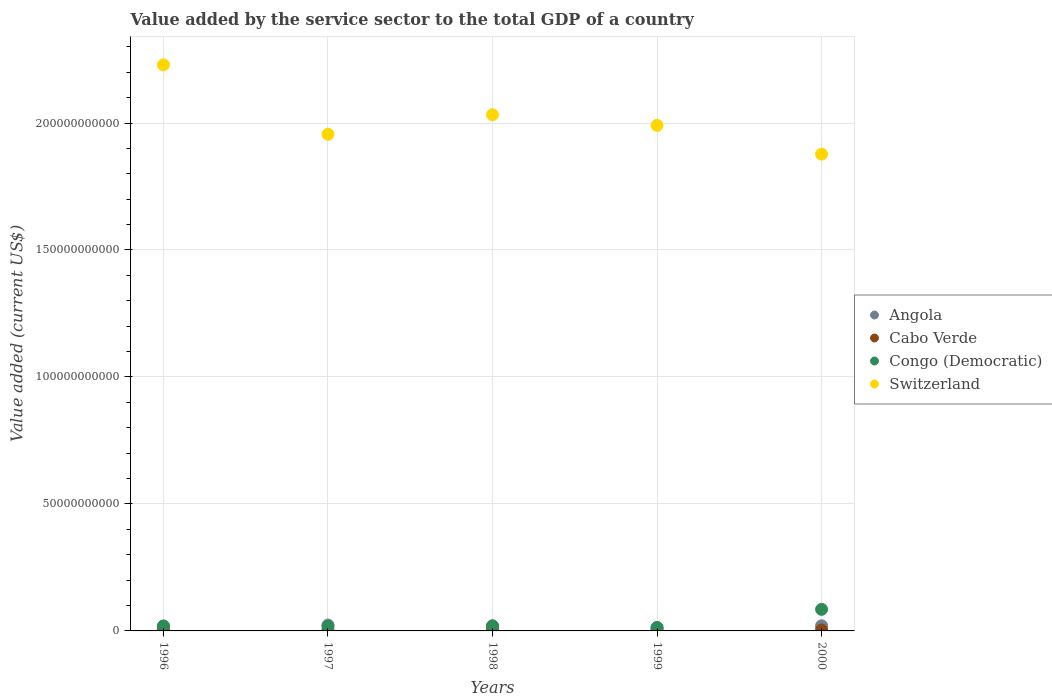How many different coloured dotlines are there?
Your response must be concise. 4. Is the number of dotlines equal to the number of legend labels?
Your answer should be compact. Yes. What is the value added by the service sector to the total GDP in Congo (Democratic) in 1997?
Make the answer very short. 1.82e+09. Across all years, what is the maximum value added by the service sector to the total GDP in Cabo Verde?
Your answer should be compact. 3.73e+08. Across all years, what is the minimum value added by the service sector to the total GDP in Congo (Democratic)?
Your response must be concise. 1.33e+09. In which year was the value added by the service sector to the total GDP in Congo (Democratic) minimum?
Give a very brief answer. 1999. What is the total value added by the service sector to the total GDP in Cabo Verde in the graph?
Offer a very short reply. 1.65e+09. What is the difference between the value added by the service sector to the total GDP in Cabo Verde in 1997 and that in 1998?
Provide a short and direct response. -2.24e+07. What is the difference between the value added by the service sector to the total GDP in Cabo Verde in 2000 and the value added by the service sector to the total GDP in Congo (Democratic) in 1996?
Provide a succinct answer. -1.58e+09. What is the average value added by the service sector to the total GDP in Angola per year?
Provide a succinct answer. 1.91e+09. In the year 2000, what is the difference between the value added by the service sector to the total GDP in Congo (Democratic) and value added by the service sector to the total GDP in Angola?
Keep it short and to the point. 6.47e+09. What is the ratio of the value added by the service sector to the total GDP in Congo (Democratic) in 1997 to that in 2000?
Offer a very short reply. 0.21. What is the difference between the highest and the second highest value added by the service sector to the total GDP in Cabo Verde?
Provide a short and direct response. 2.05e+07. What is the difference between the highest and the lowest value added by the service sector to the total GDP in Congo (Democratic)?
Your response must be concise. 7.16e+09. In how many years, is the value added by the service sector to the total GDP in Switzerland greater than the average value added by the service sector to the total GDP in Switzerland taken over all years?
Your answer should be compact. 2. Is the sum of the value added by the service sector to the total GDP in Angola in 1997 and 1998 greater than the maximum value added by the service sector to the total GDP in Congo (Democratic) across all years?
Your response must be concise. No. Is it the case that in every year, the sum of the value added by the service sector to the total GDP in Switzerland and value added by the service sector to the total GDP in Congo (Democratic)  is greater than the sum of value added by the service sector to the total GDP in Cabo Verde and value added by the service sector to the total GDP in Angola?
Provide a succinct answer. Yes. Does the value added by the service sector to the total GDP in Congo (Democratic) monotonically increase over the years?
Your response must be concise. No. Is the value added by the service sector to the total GDP in Angola strictly greater than the value added by the service sector to the total GDP in Cabo Verde over the years?
Your response must be concise. Yes. How many dotlines are there?
Give a very brief answer. 4. Are the values on the major ticks of Y-axis written in scientific E-notation?
Your answer should be very brief. No. Does the graph contain any zero values?
Offer a very short reply. No. Does the graph contain grids?
Your answer should be very brief. Yes. Where does the legend appear in the graph?
Your response must be concise. Center right. How are the legend labels stacked?
Give a very brief answer. Vertical. What is the title of the graph?
Your answer should be very brief. Value added by the service sector to the total GDP of a country. What is the label or title of the X-axis?
Offer a terse response. Years. What is the label or title of the Y-axis?
Offer a very short reply. Value added (current US$). What is the Value added (current US$) of Angola in 1996?
Provide a succinct answer. 1.89e+09. What is the Value added (current US$) of Cabo Verde in 1996?
Keep it short and to the point. 2.94e+08. What is the Value added (current US$) of Congo (Democratic) in 1996?
Keep it short and to the point. 1.93e+09. What is the Value added (current US$) of Switzerland in 1996?
Your response must be concise. 2.23e+11. What is the Value added (current US$) of Angola in 1997?
Provide a succinct answer. 2.31e+09. What is the Value added (current US$) of Cabo Verde in 1997?
Make the answer very short. 3.05e+08. What is the Value added (current US$) in Congo (Democratic) in 1997?
Ensure brevity in your answer.  1.82e+09. What is the Value added (current US$) in Switzerland in 1997?
Offer a terse response. 1.96e+11. What is the Value added (current US$) of Angola in 1998?
Your answer should be very brief. 2.02e+09. What is the Value added (current US$) in Cabo Verde in 1998?
Your answer should be compact. 3.27e+08. What is the Value added (current US$) of Congo (Democratic) in 1998?
Your response must be concise. 1.93e+09. What is the Value added (current US$) of Switzerland in 1998?
Give a very brief answer. 2.03e+11. What is the Value added (current US$) of Angola in 1999?
Your answer should be very brief. 1.29e+09. What is the Value added (current US$) in Cabo Verde in 1999?
Offer a terse response. 3.73e+08. What is the Value added (current US$) in Congo (Democratic) in 1999?
Offer a terse response. 1.33e+09. What is the Value added (current US$) in Switzerland in 1999?
Your answer should be compact. 1.99e+11. What is the Value added (current US$) in Angola in 2000?
Ensure brevity in your answer.  2.03e+09. What is the Value added (current US$) of Cabo Verde in 2000?
Provide a short and direct response. 3.53e+08. What is the Value added (current US$) of Congo (Democratic) in 2000?
Offer a terse response. 8.50e+09. What is the Value added (current US$) in Switzerland in 2000?
Your answer should be very brief. 1.88e+11. Across all years, what is the maximum Value added (current US$) of Angola?
Offer a very short reply. 2.31e+09. Across all years, what is the maximum Value added (current US$) in Cabo Verde?
Your answer should be very brief. 3.73e+08. Across all years, what is the maximum Value added (current US$) of Congo (Democratic)?
Your response must be concise. 8.50e+09. Across all years, what is the maximum Value added (current US$) in Switzerland?
Provide a succinct answer. 2.23e+11. Across all years, what is the minimum Value added (current US$) in Angola?
Your answer should be very brief. 1.29e+09. Across all years, what is the minimum Value added (current US$) of Cabo Verde?
Offer a very short reply. 2.94e+08. Across all years, what is the minimum Value added (current US$) of Congo (Democratic)?
Give a very brief answer. 1.33e+09. Across all years, what is the minimum Value added (current US$) of Switzerland?
Ensure brevity in your answer.  1.88e+11. What is the total Value added (current US$) of Angola in the graph?
Ensure brevity in your answer.  9.54e+09. What is the total Value added (current US$) of Cabo Verde in the graph?
Provide a short and direct response. 1.65e+09. What is the total Value added (current US$) in Congo (Democratic) in the graph?
Offer a terse response. 1.55e+1. What is the total Value added (current US$) in Switzerland in the graph?
Provide a succinct answer. 1.01e+12. What is the difference between the Value added (current US$) in Angola in 1996 and that in 1997?
Ensure brevity in your answer.  -4.20e+08. What is the difference between the Value added (current US$) of Cabo Verde in 1996 and that in 1997?
Offer a terse response. -1.05e+07. What is the difference between the Value added (current US$) in Congo (Democratic) in 1996 and that in 1997?
Offer a terse response. 1.12e+08. What is the difference between the Value added (current US$) in Switzerland in 1996 and that in 1997?
Provide a succinct answer. 2.73e+1. What is the difference between the Value added (current US$) in Angola in 1996 and that in 1998?
Provide a short and direct response. -1.23e+08. What is the difference between the Value added (current US$) of Cabo Verde in 1996 and that in 1998?
Offer a very short reply. -3.28e+07. What is the difference between the Value added (current US$) in Congo (Democratic) in 1996 and that in 1998?
Your response must be concise. 8.81e+06. What is the difference between the Value added (current US$) in Switzerland in 1996 and that in 1998?
Provide a succinct answer. 1.96e+1. What is the difference between the Value added (current US$) of Angola in 1996 and that in 1999?
Offer a very short reply. 6.02e+08. What is the difference between the Value added (current US$) of Cabo Verde in 1996 and that in 1999?
Give a very brief answer. -7.88e+07. What is the difference between the Value added (current US$) in Congo (Democratic) in 1996 and that in 1999?
Offer a very short reply. 6.02e+08. What is the difference between the Value added (current US$) of Switzerland in 1996 and that in 1999?
Offer a terse response. 2.39e+1. What is the difference between the Value added (current US$) of Angola in 1996 and that in 2000?
Offer a very short reply. -1.35e+08. What is the difference between the Value added (current US$) in Cabo Verde in 1996 and that in 2000?
Ensure brevity in your answer.  -5.83e+07. What is the difference between the Value added (current US$) in Congo (Democratic) in 1996 and that in 2000?
Your response must be concise. -6.56e+09. What is the difference between the Value added (current US$) in Switzerland in 1996 and that in 2000?
Your response must be concise. 3.52e+1. What is the difference between the Value added (current US$) of Angola in 1997 and that in 1998?
Offer a terse response. 2.97e+08. What is the difference between the Value added (current US$) of Cabo Verde in 1997 and that in 1998?
Your answer should be very brief. -2.24e+07. What is the difference between the Value added (current US$) in Congo (Democratic) in 1997 and that in 1998?
Give a very brief answer. -1.03e+08. What is the difference between the Value added (current US$) in Switzerland in 1997 and that in 1998?
Provide a succinct answer. -7.70e+09. What is the difference between the Value added (current US$) of Angola in 1997 and that in 1999?
Your answer should be compact. 1.02e+09. What is the difference between the Value added (current US$) of Cabo Verde in 1997 and that in 1999?
Provide a succinct answer. -6.84e+07. What is the difference between the Value added (current US$) of Congo (Democratic) in 1997 and that in 1999?
Your answer should be very brief. 4.90e+08. What is the difference between the Value added (current US$) in Switzerland in 1997 and that in 1999?
Provide a succinct answer. -3.50e+09. What is the difference between the Value added (current US$) in Angola in 1997 and that in 2000?
Keep it short and to the point. 2.85e+08. What is the difference between the Value added (current US$) in Cabo Verde in 1997 and that in 2000?
Provide a short and direct response. -4.78e+07. What is the difference between the Value added (current US$) of Congo (Democratic) in 1997 and that in 2000?
Ensure brevity in your answer.  -6.67e+09. What is the difference between the Value added (current US$) in Switzerland in 1997 and that in 2000?
Provide a short and direct response. 7.81e+09. What is the difference between the Value added (current US$) of Angola in 1998 and that in 1999?
Your answer should be compact. 7.25e+08. What is the difference between the Value added (current US$) in Cabo Verde in 1998 and that in 1999?
Provide a short and direct response. -4.60e+07. What is the difference between the Value added (current US$) in Congo (Democratic) in 1998 and that in 1999?
Your answer should be compact. 5.93e+08. What is the difference between the Value added (current US$) of Switzerland in 1998 and that in 1999?
Provide a short and direct response. 4.21e+09. What is the difference between the Value added (current US$) in Angola in 1998 and that in 2000?
Your answer should be very brief. -1.14e+07. What is the difference between the Value added (current US$) of Cabo Verde in 1998 and that in 2000?
Give a very brief answer. -2.54e+07. What is the difference between the Value added (current US$) of Congo (Democratic) in 1998 and that in 2000?
Your answer should be very brief. -6.57e+09. What is the difference between the Value added (current US$) of Switzerland in 1998 and that in 2000?
Offer a very short reply. 1.55e+1. What is the difference between the Value added (current US$) in Angola in 1999 and that in 2000?
Ensure brevity in your answer.  -7.36e+08. What is the difference between the Value added (current US$) in Cabo Verde in 1999 and that in 2000?
Ensure brevity in your answer.  2.05e+07. What is the difference between the Value added (current US$) in Congo (Democratic) in 1999 and that in 2000?
Provide a short and direct response. -7.16e+09. What is the difference between the Value added (current US$) in Switzerland in 1999 and that in 2000?
Your answer should be compact. 1.13e+1. What is the difference between the Value added (current US$) in Angola in 1996 and the Value added (current US$) in Cabo Verde in 1997?
Offer a very short reply. 1.59e+09. What is the difference between the Value added (current US$) of Angola in 1996 and the Value added (current US$) of Congo (Democratic) in 1997?
Provide a succinct answer. 7.04e+07. What is the difference between the Value added (current US$) of Angola in 1996 and the Value added (current US$) of Switzerland in 1997?
Keep it short and to the point. -1.94e+11. What is the difference between the Value added (current US$) of Cabo Verde in 1996 and the Value added (current US$) of Congo (Democratic) in 1997?
Make the answer very short. -1.53e+09. What is the difference between the Value added (current US$) of Cabo Verde in 1996 and the Value added (current US$) of Switzerland in 1997?
Provide a short and direct response. -1.95e+11. What is the difference between the Value added (current US$) in Congo (Democratic) in 1996 and the Value added (current US$) in Switzerland in 1997?
Your response must be concise. -1.94e+11. What is the difference between the Value added (current US$) of Angola in 1996 and the Value added (current US$) of Cabo Verde in 1998?
Your response must be concise. 1.57e+09. What is the difference between the Value added (current US$) of Angola in 1996 and the Value added (current US$) of Congo (Democratic) in 1998?
Give a very brief answer. -3.28e+07. What is the difference between the Value added (current US$) in Angola in 1996 and the Value added (current US$) in Switzerland in 1998?
Provide a short and direct response. -2.01e+11. What is the difference between the Value added (current US$) in Cabo Verde in 1996 and the Value added (current US$) in Congo (Democratic) in 1998?
Give a very brief answer. -1.63e+09. What is the difference between the Value added (current US$) in Cabo Verde in 1996 and the Value added (current US$) in Switzerland in 1998?
Provide a succinct answer. -2.03e+11. What is the difference between the Value added (current US$) of Congo (Democratic) in 1996 and the Value added (current US$) of Switzerland in 1998?
Keep it short and to the point. -2.01e+11. What is the difference between the Value added (current US$) in Angola in 1996 and the Value added (current US$) in Cabo Verde in 1999?
Offer a terse response. 1.52e+09. What is the difference between the Value added (current US$) of Angola in 1996 and the Value added (current US$) of Congo (Democratic) in 1999?
Keep it short and to the point. 5.60e+08. What is the difference between the Value added (current US$) of Angola in 1996 and the Value added (current US$) of Switzerland in 1999?
Offer a very short reply. -1.97e+11. What is the difference between the Value added (current US$) of Cabo Verde in 1996 and the Value added (current US$) of Congo (Democratic) in 1999?
Provide a succinct answer. -1.04e+09. What is the difference between the Value added (current US$) of Cabo Verde in 1996 and the Value added (current US$) of Switzerland in 1999?
Offer a terse response. -1.99e+11. What is the difference between the Value added (current US$) in Congo (Democratic) in 1996 and the Value added (current US$) in Switzerland in 1999?
Your answer should be very brief. -1.97e+11. What is the difference between the Value added (current US$) of Angola in 1996 and the Value added (current US$) of Cabo Verde in 2000?
Your answer should be compact. 1.54e+09. What is the difference between the Value added (current US$) in Angola in 1996 and the Value added (current US$) in Congo (Democratic) in 2000?
Offer a very short reply. -6.60e+09. What is the difference between the Value added (current US$) of Angola in 1996 and the Value added (current US$) of Switzerland in 2000?
Make the answer very short. -1.86e+11. What is the difference between the Value added (current US$) in Cabo Verde in 1996 and the Value added (current US$) in Congo (Democratic) in 2000?
Provide a short and direct response. -8.20e+09. What is the difference between the Value added (current US$) of Cabo Verde in 1996 and the Value added (current US$) of Switzerland in 2000?
Your response must be concise. -1.87e+11. What is the difference between the Value added (current US$) of Congo (Democratic) in 1996 and the Value added (current US$) of Switzerland in 2000?
Keep it short and to the point. -1.86e+11. What is the difference between the Value added (current US$) in Angola in 1997 and the Value added (current US$) in Cabo Verde in 1998?
Give a very brief answer. 1.99e+09. What is the difference between the Value added (current US$) of Angola in 1997 and the Value added (current US$) of Congo (Democratic) in 1998?
Provide a short and direct response. 3.87e+08. What is the difference between the Value added (current US$) in Angola in 1997 and the Value added (current US$) in Switzerland in 1998?
Offer a terse response. -2.01e+11. What is the difference between the Value added (current US$) in Cabo Verde in 1997 and the Value added (current US$) in Congo (Democratic) in 1998?
Your answer should be compact. -1.62e+09. What is the difference between the Value added (current US$) in Cabo Verde in 1997 and the Value added (current US$) in Switzerland in 1998?
Offer a very short reply. -2.03e+11. What is the difference between the Value added (current US$) of Congo (Democratic) in 1997 and the Value added (current US$) of Switzerland in 1998?
Provide a succinct answer. -2.01e+11. What is the difference between the Value added (current US$) in Angola in 1997 and the Value added (current US$) in Cabo Verde in 1999?
Your answer should be very brief. 1.94e+09. What is the difference between the Value added (current US$) of Angola in 1997 and the Value added (current US$) of Congo (Democratic) in 1999?
Give a very brief answer. 9.80e+08. What is the difference between the Value added (current US$) in Angola in 1997 and the Value added (current US$) in Switzerland in 1999?
Your answer should be compact. -1.97e+11. What is the difference between the Value added (current US$) in Cabo Verde in 1997 and the Value added (current US$) in Congo (Democratic) in 1999?
Give a very brief answer. -1.03e+09. What is the difference between the Value added (current US$) in Cabo Verde in 1997 and the Value added (current US$) in Switzerland in 1999?
Make the answer very short. -1.99e+11. What is the difference between the Value added (current US$) of Congo (Democratic) in 1997 and the Value added (current US$) of Switzerland in 1999?
Your response must be concise. -1.97e+11. What is the difference between the Value added (current US$) of Angola in 1997 and the Value added (current US$) of Cabo Verde in 2000?
Give a very brief answer. 1.96e+09. What is the difference between the Value added (current US$) in Angola in 1997 and the Value added (current US$) in Congo (Democratic) in 2000?
Ensure brevity in your answer.  -6.18e+09. What is the difference between the Value added (current US$) in Angola in 1997 and the Value added (current US$) in Switzerland in 2000?
Offer a very short reply. -1.85e+11. What is the difference between the Value added (current US$) of Cabo Verde in 1997 and the Value added (current US$) of Congo (Democratic) in 2000?
Give a very brief answer. -8.19e+09. What is the difference between the Value added (current US$) of Cabo Verde in 1997 and the Value added (current US$) of Switzerland in 2000?
Your answer should be very brief. -1.87e+11. What is the difference between the Value added (current US$) in Congo (Democratic) in 1997 and the Value added (current US$) in Switzerland in 2000?
Make the answer very short. -1.86e+11. What is the difference between the Value added (current US$) in Angola in 1998 and the Value added (current US$) in Cabo Verde in 1999?
Ensure brevity in your answer.  1.64e+09. What is the difference between the Value added (current US$) in Angola in 1998 and the Value added (current US$) in Congo (Democratic) in 1999?
Provide a short and direct response. 6.83e+08. What is the difference between the Value added (current US$) of Angola in 1998 and the Value added (current US$) of Switzerland in 1999?
Your answer should be compact. -1.97e+11. What is the difference between the Value added (current US$) in Cabo Verde in 1998 and the Value added (current US$) in Congo (Democratic) in 1999?
Give a very brief answer. -1.01e+09. What is the difference between the Value added (current US$) of Cabo Verde in 1998 and the Value added (current US$) of Switzerland in 1999?
Ensure brevity in your answer.  -1.99e+11. What is the difference between the Value added (current US$) in Congo (Democratic) in 1998 and the Value added (current US$) in Switzerland in 1999?
Provide a short and direct response. -1.97e+11. What is the difference between the Value added (current US$) of Angola in 1998 and the Value added (current US$) of Cabo Verde in 2000?
Make the answer very short. 1.66e+09. What is the difference between the Value added (current US$) of Angola in 1998 and the Value added (current US$) of Congo (Democratic) in 2000?
Ensure brevity in your answer.  -6.48e+09. What is the difference between the Value added (current US$) of Angola in 1998 and the Value added (current US$) of Switzerland in 2000?
Give a very brief answer. -1.86e+11. What is the difference between the Value added (current US$) of Cabo Verde in 1998 and the Value added (current US$) of Congo (Democratic) in 2000?
Provide a succinct answer. -8.17e+09. What is the difference between the Value added (current US$) of Cabo Verde in 1998 and the Value added (current US$) of Switzerland in 2000?
Offer a very short reply. -1.87e+11. What is the difference between the Value added (current US$) in Congo (Democratic) in 1998 and the Value added (current US$) in Switzerland in 2000?
Provide a succinct answer. -1.86e+11. What is the difference between the Value added (current US$) of Angola in 1999 and the Value added (current US$) of Cabo Verde in 2000?
Keep it short and to the point. 9.39e+08. What is the difference between the Value added (current US$) of Angola in 1999 and the Value added (current US$) of Congo (Democratic) in 2000?
Ensure brevity in your answer.  -7.21e+09. What is the difference between the Value added (current US$) of Angola in 1999 and the Value added (current US$) of Switzerland in 2000?
Your response must be concise. -1.86e+11. What is the difference between the Value added (current US$) of Cabo Verde in 1999 and the Value added (current US$) of Congo (Democratic) in 2000?
Provide a succinct answer. -8.12e+09. What is the difference between the Value added (current US$) in Cabo Verde in 1999 and the Value added (current US$) in Switzerland in 2000?
Your answer should be very brief. -1.87e+11. What is the difference between the Value added (current US$) in Congo (Democratic) in 1999 and the Value added (current US$) in Switzerland in 2000?
Your answer should be very brief. -1.86e+11. What is the average Value added (current US$) of Angola per year?
Give a very brief answer. 1.91e+09. What is the average Value added (current US$) in Cabo Verde per year?
Your answer should be very brief. 3.30e+08. What is the average Value added (current US$) of Congo (Democratic) per year?
Your response must be concise. 3.10e+09. What is the average Value added (current US$) of Switzerland per year?
Provide a short and direct response. 2.02e+11. In the year 1996, what is the difference between the Value added (current US$) of Angola and Value added (current US$) of Cabo Verde?
Your answer should be very brief. 1.60e+09. In the year 1996, what is the difference between the Value added (current US$) in Angola and Value added (current US$) in Congo (Democratic)?
Ensure brevity in your answer.  -4.16e+07. In the year 1996, what is the difference between the Value added (current US$) of Angola and Value added (current US$) of Switzerland?
Your answer should be very brief. -2.21e+11. In the year 1996, what is the difference between the Value added (current US$) of Cabo Verde and Value added (current US$) of Congo (Democratic)?
Make the answer very short. -1.64e+09. In the year 1996, what is the difference between the Value added (current US$) of Cabo Verde and Value added (current US$) of Switzerland?
Make the answer very short. -2.23e+11. In the year 1996, what is the difference between the Value added (current US$) of Congo (Democratic) and Value added (current US$) of Switzerland?
Provide a succinct answer. -2.21e+11. In the year 1997, what is the difference between the Value added (current US$) in Angola and Value added (current US$) in Cabo Verde?
Offer a terse response. 2.01e+09. In the year 1997, what is the difference between the Value added (current US$) in Angola and Value added (current US$) in Congo (Democratic)?
Offer a terse response. 4.90e+08. In the year 1997, what is the difference between the Value added (current US$) of Angola and Value added (current US$) of Switzerland?
Make the answer very short. -1.93e+11. In the year 1997, what is the difference between the Value added (current US$) in Cabo Verde and Value added (current US$) in Congo (Democratic)?
Offer a terse response. -1.52e+09. In the year 1997, what is the difference between the Value added (current US$) in Cabo Verde and Value added (current US$) in Switzerland?
Offer a very short reply. -1.95e+11. In the year 1997, what is the difference between the Value added (current US$) of Congo (Democratic) and Value added (current US$) of Switzerland?
Provide a succinct answer. -1.94e+11. In the year 1998, what is the difference between the Value added (current US$) of Angola and Value added (current US$) of Cabo Verde?
Your answer should be very brief. 1.69e+09. In the year 1998, what is the difference between the Value added (current US$) of Angola and Value added (current US$) of Congo (Democratic)?
Provide a short and direct response. 9.05e+07. In the year 1998, what is the difference between the Value added (current US$) of Angola and Value added (current US$) of Switzerland?
Ensure brevity in your answer.  -2.01e+11. In the year 1998, what is the difference between the Value added (current US$) of Cabo Verde and Value added (current US$) of Congo (Democratic)?
Provide a succinct answer. -1.60e+09. In the year 1998, what is the difference between the Value added (current US$) in Cabo Verde and Value added (current US$) in Switzerland?
Your answer should be very brief. -2.03e+11. In the year 1998, what is the difference between the Value added (current US$) of Congo (Democratic) and Value added (current US$) of Switzerland?
Your answer should be very brief. -2.01e+11. In the year 1999, what is the difference between the Value added (current US$) in Angola and Value added (current US$) in Cabo Verde?
Provide a succinct answer. 9.19e+08. In the year 1999, what is the difference between the Value added (current US$) in Angola and Value added (current US$) in Congo (Democratic)?
Give a very brief answer. -4.14e+07. In the year 1999, what is the difference between the Value added (current US$) in Angola and Value added (current US$) in Switzerland?
Make the answer very short. -1.98e+11. In the year 1999, what is the difference between the Value added (current US$) of Cabo Verde and Value added (current US$) of Congo (Democratic)?
Give a very brief answer. -9.60e+08. In the year 1999, what is the difference between the Value added (current US$) in Cabo Verde and Value added (current US$) in Switzerland?
Offer a very short reply. -1.99e+11. In the year 1999, what is the difference between the Value added (current US$) in Congo (Democratic) and Value added (current US$) in Switzerland?
Provide a short and direct response. -1.98e+11. In the year 2000, what is the difference between the Value added (current US$) of Angola and Value added (current US$) of Cabo Verde?
Give a very brief answer. 1.68e+09. In the year 2000, what is the difference between the Value added (current US$) of Angola and Value added (current US$) of Congo (Democratic)?
Offer a very short reply. -6.47e+09. In the year 2000, what is the difference between the Value added (current US$) of Angola and Value added (current US$) of Switzerland?
Your answer should be compact. -1.86e+11. In the year 2000, what is the difference between the Value added (current US$) of Cabo Verde and Value added (current US$) of Congo (Democratic)?
Make the answer very short. -8.14e+09. In the year 2000, what is the difference between the Value added (current US$) in Cabo Verde and Value added (current US$) in Switzerland?
Ensure brevity in your answer.  -1.87e+11. In the year 2000, what is the difference between the Value added (current US$) of Congo (Democratic) and Value added (current US$) of Switzerland?
Ensure brevity in your answer.  -1.79e+11. What is the ratio of the Value added (current US$) in Angola in 1996 to that in 1997?
Provide a succinct answer. 0.82. What is the ratio of the Value added (current US$) of Cabo Verde in 1996 to that in 1997?
Offer a terse response. 0.97. What is the ratio of the Value added (current US$) of Congo (Democratic) in 1996 to that in 1997?
Your answer should be compact. 1.06. What is the ratio of the Value added (current US$) of Switzerland in 1996 to that in 1997?
Ensure brevity in your answer.  1.14. What is the ratio of the Value added (current US$) of Angola in 1996 to that in 1998?
Your response must be concise. 0.94. What is the ratio of the Value added (current US$) in Cabo Verde in 1996 to that in 1998?
Give a very brief answer. 0.9. What is the ratio of the Value added (current US$) of Congo (Democratic) in 1996 to that in 1998?
Your answer should be very brief. 1. What is the ratio of the Value added (current US$) in Switzerland in 1996 to that in 1998?
Your answer should be very brief. 1.1. What is the ratio of the Value added (current US$) of Angola in 1996 to that in 1999?
Make the answer very short. 1.47. What is the ratio of the Value added (current US$) of Cabo Verde in 1996 to that in 1999?
Offer a very short reply. 0.79. What is the ratio of the Value added (current US$) of Congo (Democratic) in 1996 to that in 1999?
Your answer should be very brief. 1.45. What is the ratio of the Value added (current US$) in Switzerland in 1996 to that in 1999?
Your answer should be very brief. 1.12. What is the ratio of the Value added (current US$) in Angola in 1996 to that in 2000?
Your answer should be very brief. 0.93. What is the ratio of the Value added (current US$) of Cabo Verde in 1996 to that in 2000?
Your response must be concise. 0.83. What is the ratio of the Value added (current US$) of Congo (Democratic) in 1996 to that in 2000?
Make the answer very short. 0.23. What is the ratio of the Value added (current US$) in Switzerland in 1996 to that in 2000?
Offer a terse response. 1.19. What is the ratio of the Value added (current US$) in Angola in 1997 to that in 1998?
Your response must be concise. 1.15. What is the ratio of the Value added (current US$) in Cabo Verde in 1997 to that in 1998?
Your response must be concise. 0.93. What is the ratio of the Value added (current US$) of Congo (Democratic) in 1997 to that in 1998?
Your answer should be compact. 0.95. What is the ratio of the Value added (current US$) of Switzerland in 1997 to that in 1998?
Your answer should be very brief. 0.96. What is the ratio of the Value added (current US$) of Angola in 1997 to that in 1999?
Ensure brevity in your answer.  1.79. What is the ratio of the Value added (current US$) of Cabo Verde in 1997 to that in 1999?
Offer a very short reply. 0.82. What is the ratio of the Value added (current US$) of Congo (Democratic) in 1997 to that in 1999?
Offer a very short reply. 1.37. What is the ratio of the Value added (current US$) in Switzerland in 1997 to that in 1999?
Provide a succinct answer. 0.98. What is the ratio of the Value added (current US$) in Angola in 1997 to that in 2000?
Your answer should be compact. 1.14. What is the ratio of the Value added (current US$) in Cabo Verde in 1997 to that in 2000?
Offer a terse response. 0.86. What is the ratio of the Value added (current US$) of Congo (Democratic) in 1997 to that in 2000?
Provide a short and direct response. 0.21. What is the ratio of the Value added (current US$) in Switzerland in 1997 to that in 2000?
Ensure brevity in your answer.  1.04. What is the ratio of the Value added (current US$) in Angola in 1998 to that in 1999?
Offer a terse response. 1.56. What is the ratio of the Value added (current US$) of Cabo Verde in 1998 to that in 1999?
Offer a very short reply. 0.88. What is the ratio of the Value added (current US$) in Congo (Democratic) in 1998 to that in 1999?
Provide a short and direct response. 1.44. What is the ratio of the Value added (current US$) in Switzerland in 1998 to that in 1999?
Give a very brief answer. 1.02. What is the ratio of the Value added (current US$) of Cabo Verde in 1998 to that in 2000?
Offer a very short reply. 0.93. What is the ratio of the Value added (current US$) of Congo (Democratic) in 1998 to that in 2000?
Your response must be concise. 0.23. What is the ratio of the Value added (current US$) of Switzerland in 1998 to that in 2000?
Ensure brevity in your answer.  1.08. What is the ratio of the Value added (current US$) in Angola in 1999 to that in 2000?
Your answer should be compact. 0.64. What is the ratio of the Value added (current US$) in Cabo Verde in 1999 to that in 2000?
Give a very brief answer. 1.06. What is the ratio of the Value added (current US$) in Congo (Democratic) in 1999 to that in 2000?
Your answer should be very brief. 0.16. What is the ratio of the Value added (current US$) in Switzerland in 1999 to that in 2000?
Your answer should be very brief. 1.06. What is the difference between the highest and the second highest Value added (current US$) in Angola?
Your answer should be compact. 2.85e+08. What is the difference between the highest and the second highest Value added (current US$) in Cabo Verde?
Ensure brevity in your answer.  2.05e+07. What is the difference between the highest and the second highest Value added (current US$) in Congo (Democratic)?
Your response must be concise. 6.56e+09. What is the difference between the highest and the second highest Value added (current US$) in Switzerland?
Provide a short and direct response. 1.96e+1. What is the difference between the highest and the lowest Value added (current US$) in Angola?
Keep it short and to the point. 1.02e+09. What is the difference between the highest and the lowest Value added (current US$) of Cabo Verde?
Offer a very short reply. 7.88e+07. What is the difference between the highest and the lowest Value added (current US$) of Congo (Democratic)?
Offer a very short reply. 7.16e+09. What is the difference between the highest and the lowest Value added (current US$) of Switzerland?
Provide a succinct answer. 3.52e+1. 